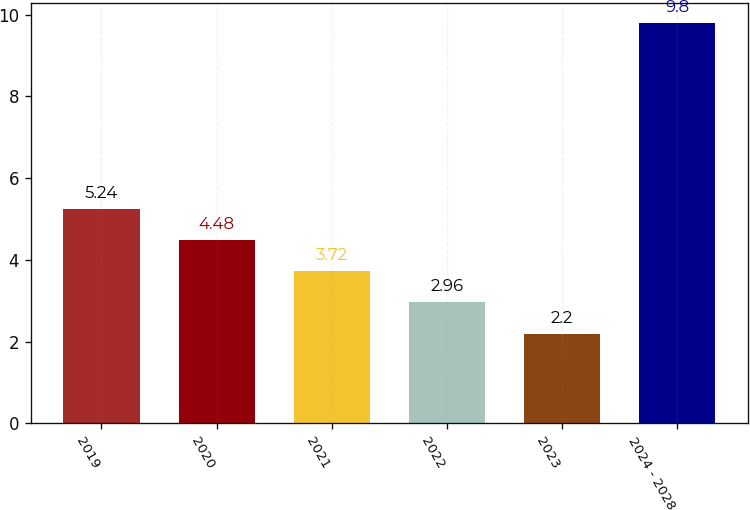Convert chart to OTSL. <chart><loc_0><loc_0><loc_500><loc_500><bar_chart><fcel>2019<fcel>2020<fcel>2021<fcel>2022<fcel>2023<fcel>2024 - 2028<nl><fcel>5.24<fcel>4.48<fcel>3.72<fcel>2.96<fcel>2.2<fcel>9.8<nl></chart> 